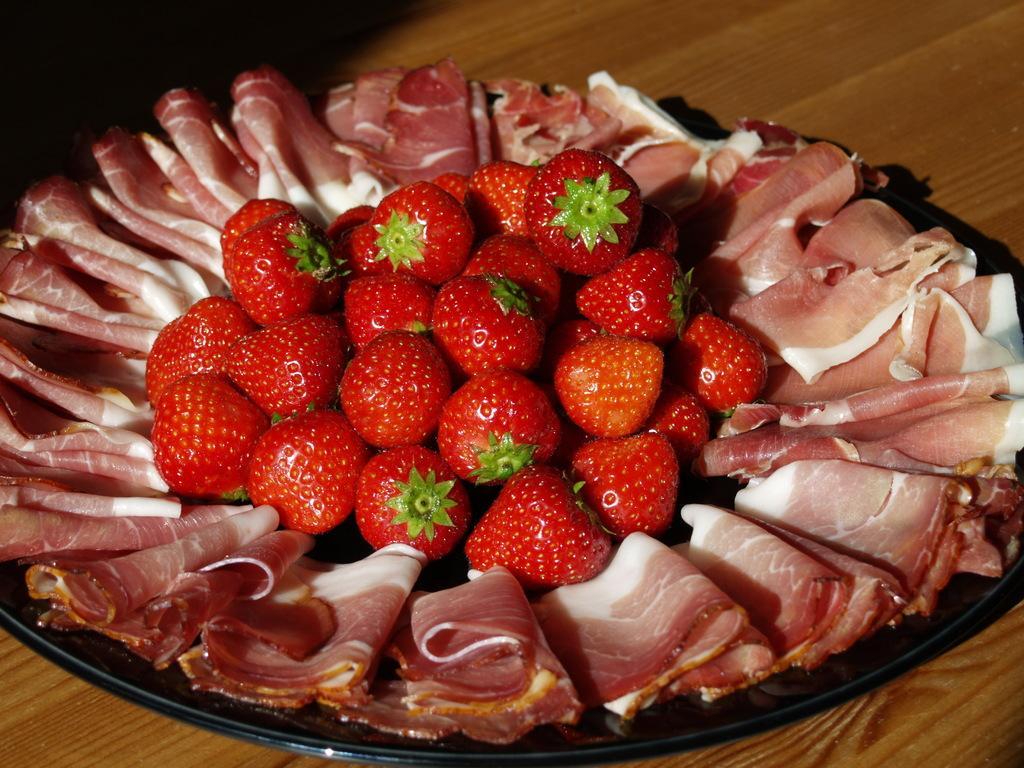How would you summarize this image in a sentence or two? In this image, we can see some strawberries and meat on the plate. 